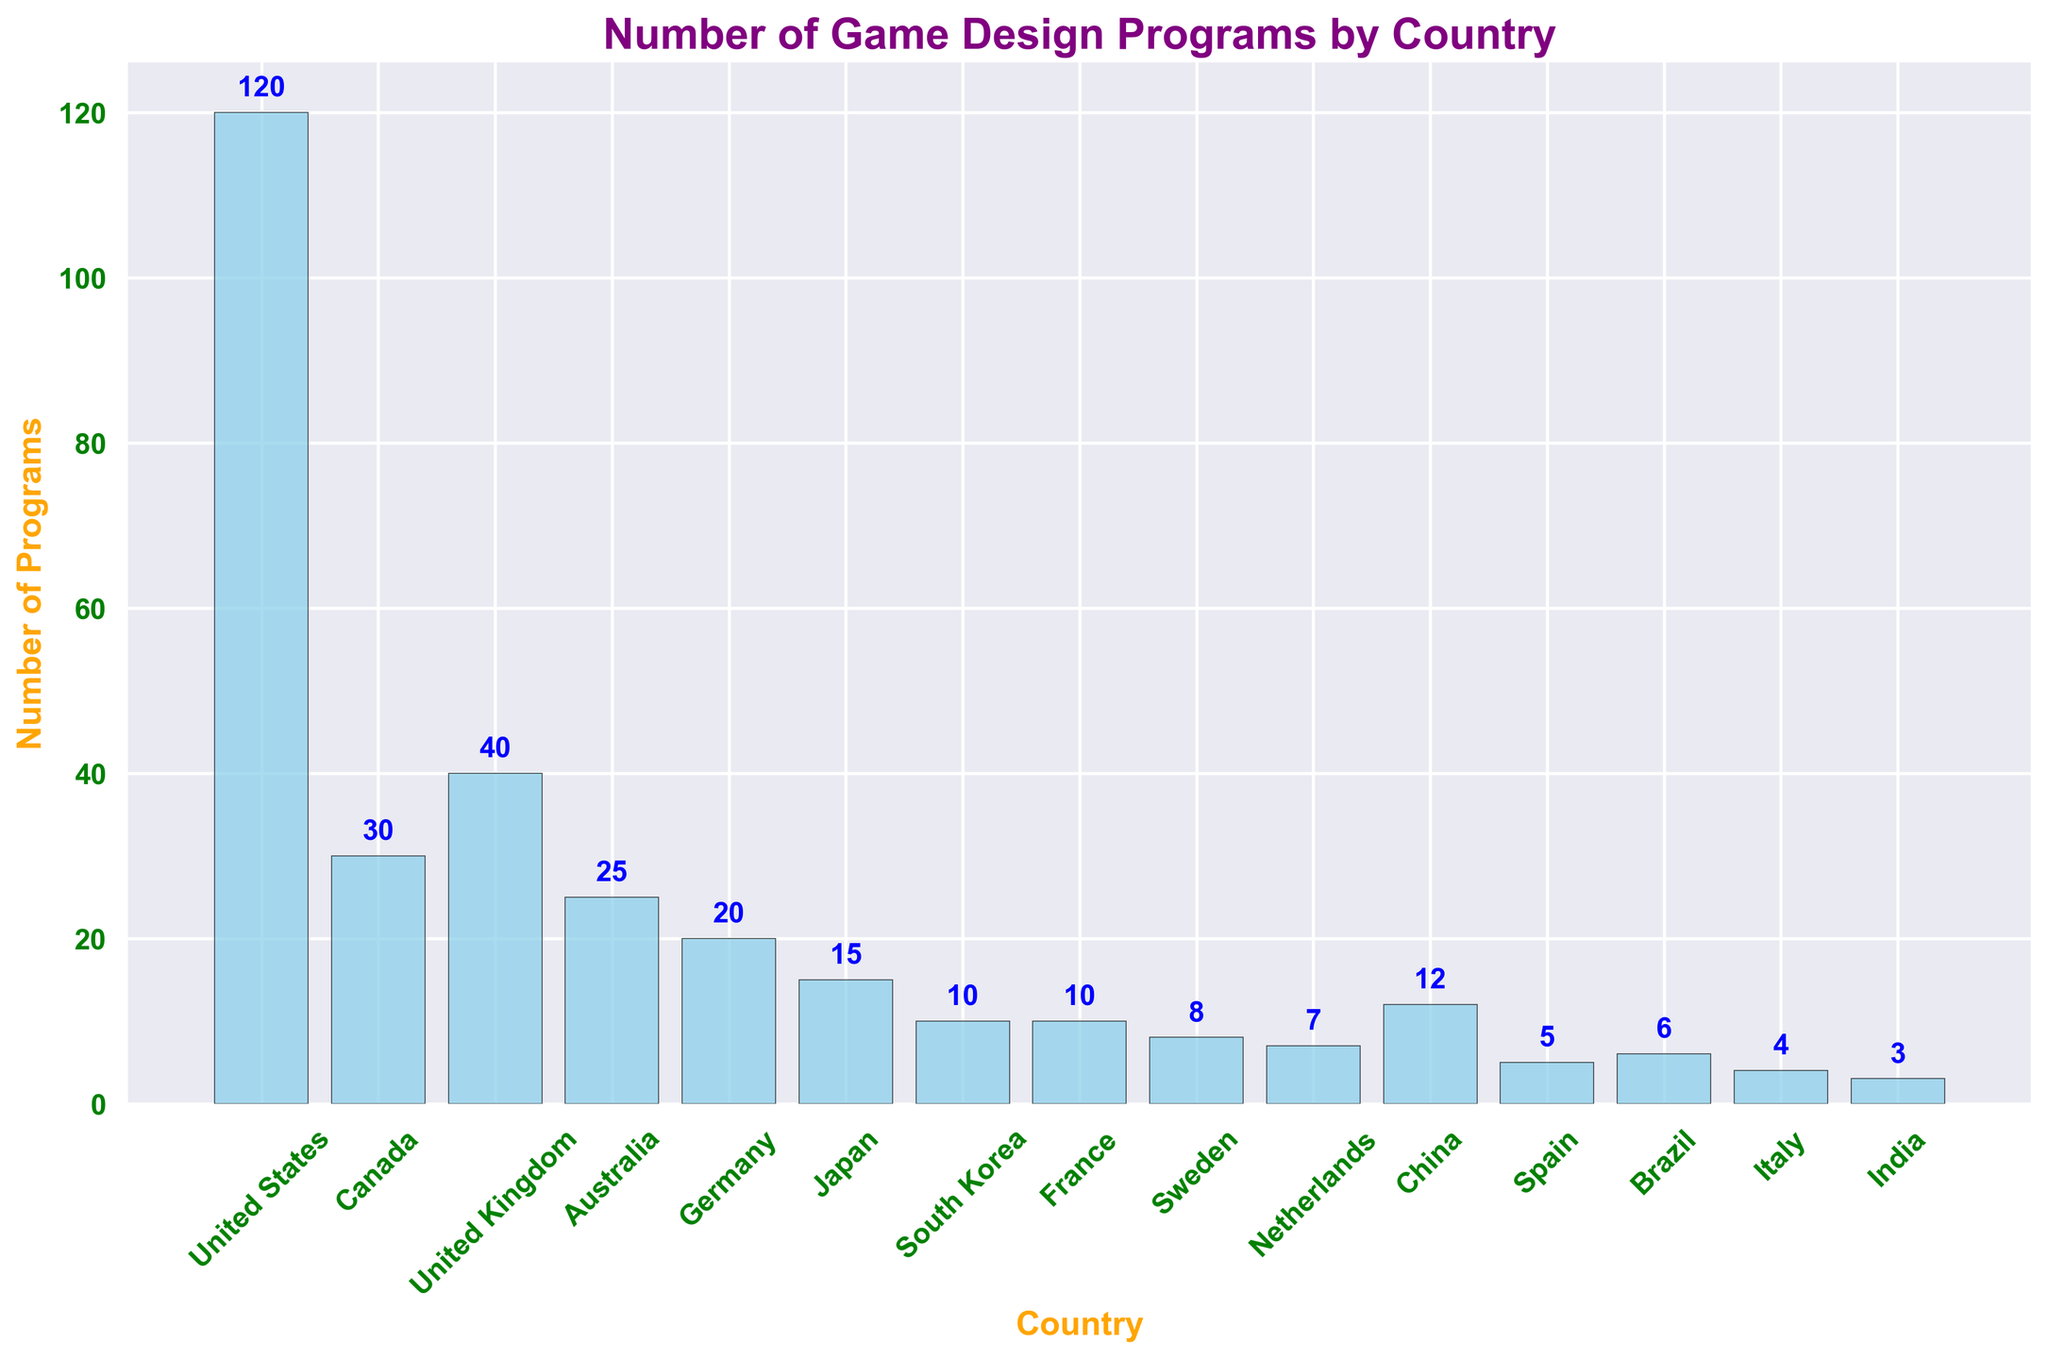Which country offers the most game design programs? The figure shows the United States having the tallest bar among all the countries, indicating it offers the most programs.
Answer: United States Which countries offer more than 20 game design programs? Examine the countries with bars extending above the 20 programs mark: United States, Canada, United Kingdom, and Australia.
Answer: United States, Canada, United Kingdom, Australia Compare the number of programs offered by Germany and Japan. Which country offers more programs? By comparing the height of the bars for Germany and Japan, Germany's bar is taller, indicating more programs.
Answer: Germany What is the total number of game design programs offered by Canada and Australia combined? Sum the programs offered by Canada (30) and Australia (25): 30 + 25 = 55.
Answer: 55 What is the difference in the number of programs between the United States and China? Subtract the number of programs in China (12) from the United States (120): 120 - 12 = 108.
Answer: 108 What is the average number of game design programs provided by Germany, Japan, and South Korea? Sum programs offered by Germany (20), Japan (15), and South Korea (10) and divide by 3: (20 + 15 + 10) / 3 = 45 / 3 = 15.
Answer: 15 How many countries offer fewer than 10 game design programs? Count countries with bars below the 10 mark on the figure: South Korea, France, Sweden, Netherlands, Spain, Brazil, Italy, and India. 8 countries.
Answer: 8 Which country is represented by the second tallest bar in the figure? The second tallest bar after the United States is from the United Kingdom.
Answer: United Kingdom What is the combined number of programs offered by the countries with the smallest number of programs? Countries with the smallest number (India: 3, Italy: 4) have a combined total of 7 (3+4).
Answer: 7 Is the number of programs in France more than 5 but less than 15? The height of France’s bar is at 10, which is between 5 and 15.
Answer: Yes 